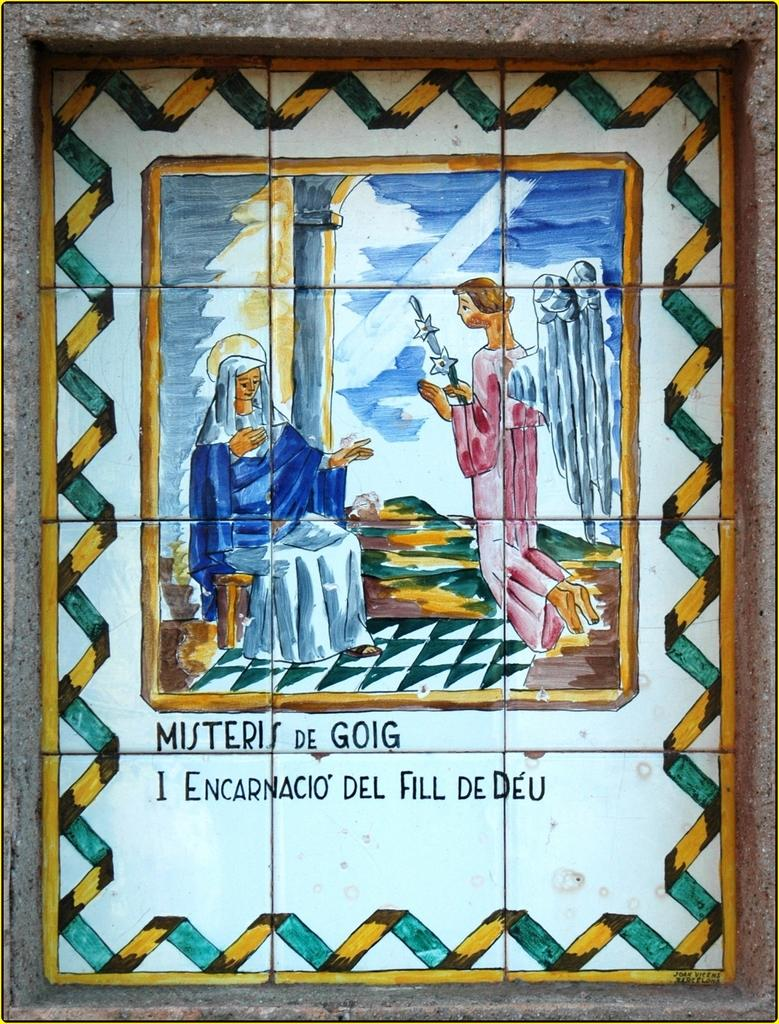What is hanging on the wall in the image? There is a photo frame on the wall. What can be seen inside the photo frame? The photo frame contains depictions of people. Are there any words or letters in the photo frame? Yes, there is text in the photo frame. What type of treatment is the stranger receiving in the photo frame? There is no stranger present in the photo frame, and therefore no treatment can be observed. 